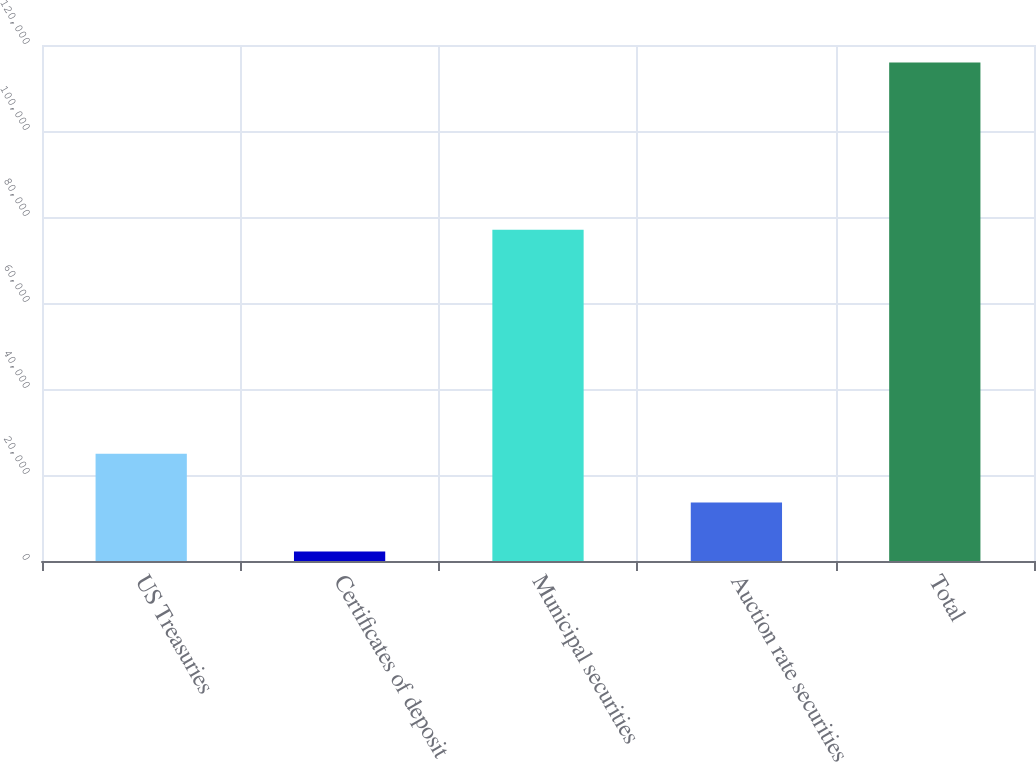<chart> <loc_0><loc_0><loc_500><loc_500><bar_chart><fcel>US Treasuries<fcel>Certificates of deposit<fcel>Municipal securities<fcel>Auction rate securities<fcel>Total<nl><fcel>24951.2<fcel>2201<fcel>77038<fcel>13576.1<fcel>115952<nl></chart> 